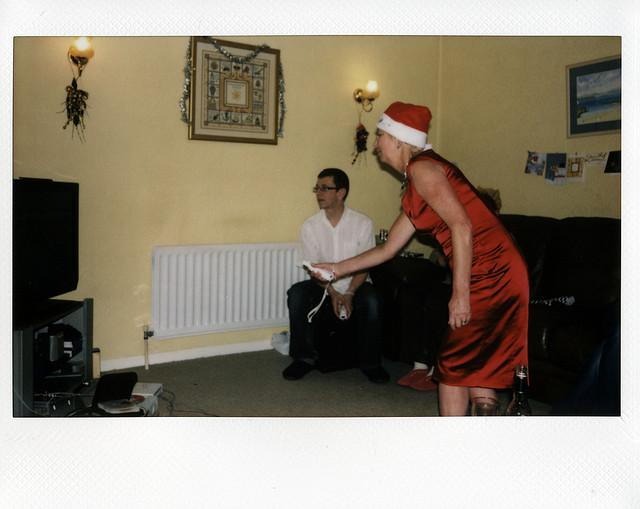What gift did the woman seen here get for Christmas? Please explain your reasoning. wii. She is holding the remote from this video game system. 